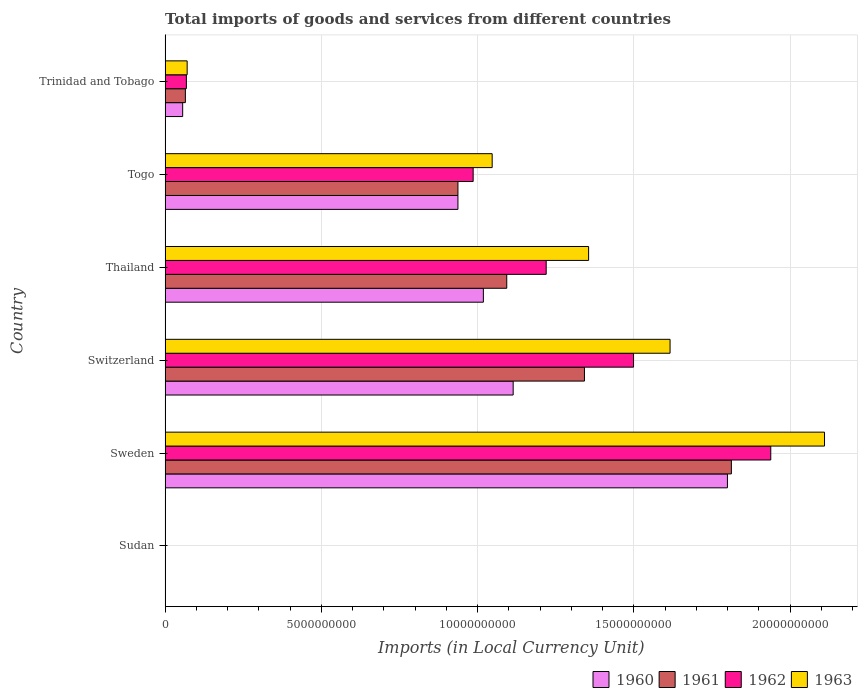How many groups of bars are there?
Your answer should be very brief. 6. Are the number of bars per tick equal to the number of legend labels?
Provide a succinct answer. Yes. Are the number of bars on each tick of the Y-axis equal?
Ensure brevity in your answer.  Yes. How many bars are there on the 6th tick from the top?
Offer a terse response. 4. What is the label of the 5th group of bars from the top?
Your answer should be compact. Sweden. In how many cases, is the number of bars for a given country not equal to the number of legend labels?
Your answer should be very brief. 0. What is the Amount of goods and services imports in 1961 in Trinidad and Tobago?
Provide a succinct answer. 6.49e+08. Across all countries, what is the maximum Amount of goods and services imports in 1962?
Provide a short and direct response. 1.94e+1. Across all countries, what is the minimum Amount of goods and services imports in 1963?
Your answer should be compact. 8.49e+04. In which country was the Amount of goods and services imports in 1962 minimum?
Offer a terse response. Sudan. What is the total Amount of goods and services imports in 1960 in the graph?
Ensure brevity in your answer.  4.92e+1. What is the difference between the Amount of goods and services imports in 1963 in Sudan and that in Sweden?
Offer a terse response. -2.11e+1. What is the difference between the Amount of goods and services imports in 1960 in Togo and the Amount of goods and services imports in 1961 in Thailand?
Your answer should be very brief. -1.56e+09. What is the average Amount of goods and services imports in 1961 per country?
Give a very brief answer. 8.75e+09. What is the difference between the Amount of goods and services imports in 1962 and Amount of goods and services imports in 1961 in Sweden?
Offer a terse response. 1.26e+09. In how many countries, is the Amount of goods and services imports in 1961 greater than 13000000000 LCU?
Your response must be concise. 2. What is the ratio of the Amount of goods and services imports in 1962 in Sudan to that in Togo?
Keep it short and to the point. 7.0611131633880305e-6. What is the difference between the highest and the second highest Amount of goods and services imports in 1962?
Your response must be concise. 4.39e+09. What is the difference between the highest and the lowest Amount of goods and services imports in 1961?
Make the answer very short. 1.81e+1. Is it the case that in every country, the sum of the Amount of goods and services imports in 1960 and Amount of goods and services imports in 1963 is greater than the sum of Amount of goods and services imports in 1962 and Amount of goods and services imports in 1961?
Give a very brief answer. No. What does the 1st bar from the top in Thailand represents?
Offer a terse response. 1963. Are all the bars in the graph horizontal?
Your response must be concise. Yes. How many countries are there in the graph?
Provide a short and direct response. 6. What is the difference between two consecutive major ticks on the X-axis?
Keep it short and to the point. 5.00e+09. Where does the legend appear in the graph?
Make the answer very short. Bottom right. What is the title of the graph?
Offer a terse response. Total imports of goods and services from different countries. What is the label or title of the X-axis?
Provide a succinct answer. Imports (in Local Currency Unit). What is the label or title of the Y-axis?
Give a very brief answer. Country. What is the Imports (in Local Currency Unit) of 1960 in Sudan?
Your answer should be very brief. 5.10e+04. What is the Imports (in Local Currency Unit) of 1961 in Sudan?
Your answer should be compact. 6.11e+04. What is the Imports (in Local Currency Unit) of 1962 in Sudan?
Your answer should be very brief. 6.96e+04. What is the Imports (in Local Currency Unit) of 1963 in Sudan?
Keep it short and to the point. 8.49e+04. What is the Imports (in Local Currency Unit) of 1960 in Sweden?
Your response must be concise. 1.80e+1. What is the Imports (in Local Currency Unit) of 1961 in Sweden?
Offer a terse response. 1.81e+1. What is the Imports (in Local Currency Unit) in 1962 in Sweden?
Provide a succinct answer. 1.94e+1. What is the Imports (in Local Currency Unit) of 1963 in Sweden?
Provide a short and direct response. 2.11e+1. What is the Imports (in Local Currency Unit) of 1960 in Switzerland?
Offer a very short reply. 1.11e+1. What is the Imports (in Local Currency Unit) in 1961 in Switzerland?
Make the answer very short. 1.34e+1. What is the Imports (in Local Currency Unit) of 1962 in Switzerland?
Offer a very short reply. 1.50e+1. What is the Imports (in Local Currency Unit) of 1963 in Switzerland?
Keep it short and to the point. 1.62e+1. What is the Imports (in Local Currency Unit) in 1960 in Thailand?
Your answer should be compact. 1.02e+1. What is the Imports (in Local Currency Unit) of 1961 in Thailand?
Ensure brevity in your answer.  1.09e+1. What is the Imports (in Local Currency Unit) of 1962 in Thailand?
Make the answer very short. 1.22e+1. What is the Imports (in Local Currency Unit) in 1963 in Thailand?
Offer a very short reply. 1.36e+1. What is the Imports (in Local Currency Unit) in 1960 in Togo?
Make the answer very short. 9.37e+09. What is the Imports (in Local Currency Unit) in 1961 in Togo?
Your answer should be compact. 9.37e+09. What is the Imports (in Local Currency Unit) in 1962 in Togo?
Make the answer very short. 9.86e+09. What is the Imports (in Local Currency Unit) of 1963 in Togo?
Offer a terse response. 1.05e+1. What is the Imports (in Local Currency Unit) of 1960 in Trinidad and Tobago?
Make the answer very short. 5.62e+08. What is the Imports (in Local Currency Unit) of 1961 in Trinidad and Tobago?
Offer a very short reply. 6.49e+08. What is the Imports (in Local Currency Unit) of 1962 in Trinidad and Tobago?
Give a very brief answer. 6.81e+08. What is the Imports (in Local Currency Unit) in 1963 in Trinidad and Tobago?
Offer a terse response. 7.06e+08. Across all countries, what is the maximum Imports (in Local Currency Unit) in 1960?
Provide a short and direct response. 1.80e+1. Across all countries, what is the maximum Imports (in Local Currency Unit) in 1961?
Offer a terse response. 1.81e+1. Across all countries, what is the maximum Imports (in Local Currency Unit) in 1962?
Offer a terse response. 1.94e+1. Across all countries, what is the maximum Imports (in Local Currency Unit) of 1963?
Your answer should be very brief. 2.11e+1. Across all countries, what is the minimum Imports (in Local Currency Unit) in 1960?
Your answer should be very brief. 5.10e+04. Across all countries, what is the minimum Imports (in Local Currency Unit) of 1961?
Your answer should be very brief. 6.11e+04. Across all countries, what is the minimum Imports (in Local Currency Unit) in 1962?
Give a very brief answer. 6.96e+04. Across all countries, what is the minimum Imports (in Local Currency Unit) of 1963?
Offer a terse response. 8.49e+04. What is the total Imports (in Local Currency Unit) of 1960 in the graph?
Provide a short and direct response. 4.92e+1. What is the total Imports (in Local Currency Unit) of 1961 in the graph?
Make the answer very short. 5.25e+1. What is the total Imports (in Local Currency Unit) in 1962 in the graph?
Ensure brevity in your answer.  5.71e+1. What is the total Imports (in Local Currency Unit) of 1963 in the graph?
Your answer should be compact. 6.20e+1. What is the difference between the Imports (in Local Currency Unit) of 1960 in Sudan and that in Sweden?
Your response must be concise. -1.80e+1. What is the difference between the Imports (in Local Currency Unit) of 1961 in Sudan and that in Sweden?
Make the answer very short. -1.81e+1. What is the difference between the Imports (in Local Currency Unit) of 1962 in Sudan and that in Sweden?
Offer a very short reply. -1.94e+1. What is the difference between the Imports (in Local Currency Unit) in 1963 in Sudan and that in Sweden?
Make the answer very short. -2.11e+1. What is the difference between the Imports (in Local Currency Unit) of 1960 in Sudan and that in Switzerland?
Make the answer very short. -1.11e+1. What is the difference between the Imports (in Local Currency Unit) of 1961 in Sudan and that in Switzerland?
Your answer should be compact. -1.34e+1. What is the difference between the Imports (in Local Currency Unit) in 1962 in Sudan and that in Switzerland?
Make the answer very short. -1.50e+1. What is the difference between the Imports (in Local Currency Unit) of 1963 in Sudan and that in Switzerland?
Your answer should be very brief. -1.62e+1. What is the difference between the Imports (in Local Currency Unit) in 1960 in Sudan and that in Thailand?
Give a very brief answer. -1.02e+1. What is the difference between the Imports (in Local Currency Unit) of 1961 in Sudan and that in Thailand?
Your answer should be very brief. -1.09e+1. What is the difference between the Imports (in Local Currency Unit) in 1962 in Sudan and that in Thailand?
Make the answer very short. -1.22e+1. What is the difference between the Imports (in Local Currency Unit) in 1963 in Sudan and that in Thailand?
Your answer should be very brief. -1.36e+1. What is the difference between the Imports (in Local Currency Unit) in 1960 in Sudan and that in Togo?
Provide a succinct answer. -9.37e+09. What is the difference between the Imports (in Local Currency Unit) in 1961 in Sudan and that in Togo?
Offer a terse response. -9.37e+09. What is the difference between the Imports (in Local Currency Unit) of 1962 in Sudan and that in Togo?
Provide a succinct answer. -9.86e+09. What is the difference between the Imports (in Local Currency Unit) of 1963 in Sudan and that in Togo?
Give a very brief answer. -1.05e+1. What is the difference between the Imports (in Local Currency Unit) in 1960 in Sudan and that in Trinidad and Tobago?
Ensure brevity in your answer.  -5.62e+08. What is the difference between the Imports (in Local Currency Unit) of 1961 in Sudan and that in Trinidad and Tobago?
Offer a very short reply. -6.49e+08. What is the difference between the Imports (in Local Currency Unit) of 1962 in Sudan and that in Trinidad and Tobago?
Your answer should be compact. -6.81e+08. What is the difference between the Imports (in Local Currency Unit) in 1963 in Sudan and that in Trinidad and Tobago?
Offer a very short reply. -7.06e+08. What is the difference between the Imports (in Local Currency Unit) in 1960 in Sweden and that in Switzerland?
Provide a short and direct response. 6.86e+09. What is the difference between the Imports (in Local Currency Unit) in 1961 in Sweden and that in Switzerland?
Offer a very short reply. 4.70e+09. What is the difference between the Imports (in Local Currency Unit) of 1962 in Sweden and that in Switzerland?
Keep it short and to the point. 4.39e+09. What is the difference between the Imports (in Local Currency Unit) in 1963 in Sweden and that in Switzerland?
Offer a terse response. 4.94e+09. What is the difference between the Imports (in Local Currency Unit) of 1960 in Sweden and that in Thailand?
Offer a terse response. 7.81e+09. What is the difference between the Imports (in Local Currency Unit) in 1961 in Sweden and that in Thailand?
Your answer should be compact. 7.19e+09. What is the difference between the Imports (in Local Currency Unit) in 1962 in Sweden and that in Thailand?
Your answer should be very brief. 7.19e+09. What is the difference between the Imports (in Local Currency Unit) in 1963 in Sweden and that in Thailand?
Keep it short and to the point. 7.55e+09. What is the difference between the Imports (in Local Currency Unit) in 1960 in Sweden and that in Togo?
Offer a terse response. 8.62e+09. What is the difference between the Imports (in Local Currency Unit) of 1961 in Sweden and that in Togo?
Offer a very short reply. 8.75e+09. What is the difference between the Imports (in Local Currency Unit) of 1962 in Sweden and that in Togo?
Keep it short and to the point. 9.52e+09. What is the difference between the Imports (in Local Currency Unit) of 1963 in Sweden and that in Togo?
Provide a succinct answer. 1.06e+1. What is the difference between the Imports (in Local Currency Unit) of 1960 in Sweden and that in Trinidad and Tobago?
Offer a terse response. 1.74e+1. What is the difference between the Imports (in Local Currency Unit) of 1961 in Sweden and that in Trinidad and Tobago?
Offer a terse response. 1.75e+1. What is the difference between the Imports (in Local Currency Unit) of 1962 in Sweden and that in Trinidad and Tobago?
Your answer should be compact. 1.87e+1. What is the difference between the Imports (in Local Currency Unit) in 1963 in Sweden and that in Trinidad and Tobago?
Your answer should be very brief. 2.04e+1. What is the difference between the Imports (in Local Currency Unit) of 1960 in Switzerland and that in Thailand?
Give a very brief answer. 9.53e+08. What is the difference between the Imports (in Local Currency Unit) in 1961 in Switzerland and that in Thailand?
Your answer should be compact. 2.49e+09. What is the difference between the Imports (in Local Currency Unit) of 1962 in Switzerland and that in Thailand?
Provide a succinct answer. 2.80e+09. What is the difference between the Imports (in Local Currency Unit) in 1963 in Switzerland and that in Thailand?
Your answer should be compact. 2.61e+09. What is the difference between the Imports (in Local Currency Unit) in 1960 in Switzerland and that in Togo?
Offer a very short reply. 1.77e+09. What is the difference between the Imports (in Local Currency Unit) of 1961 in Switzerland and that in Togo?
Make the answer very short. 4.05e+09. What is the difference between the Imports (in Local Currency Unit) of 1962 in Switzerland and that in Togo?
Provide a succinct answer. 5.13e+09. What is the difference between the Imports (in Local Currency Unit) in 1963 in Switzerland and that in Togo?
Make the answer very short. 5.69e+09. What is the difference between the Imports (in Local Currency Unit) of 1960 in Switzerland and that in Trinidad and Tobago?
Provide a succinct answer. 1.06e+1. What is the difference between the Imports (in Local Currency Unit) in 1961 in Switzerland and that in Trinidad and Tobago?
Offer a terse response. 1.28e+1. What is the difference between the Imports (in Local Currency Unit) in 1962 in Switzerland and that in Trinidad and Tobago?
Offer a terse response. 1.43e+1. What is the difference between the Imports (in Local Currency Unit) in 1963 in Switzerland and that in Trinidad and Tobago?
Your answer should be very brief. 1.55e+1. What is the difference between the Imports (in Local Currency Unit) in 1960 in Thailand and that in Togo?
Offer a very short reply. 8.14e+08. What is the difference between the Imports (in Local Currency Unit) of 1961 in Thailand and that in Togo?
Offer a very short reply. 1.56e+09. What is the difference between the Imports (in Local Currency Unit) in 1962 in Thailand and that in Togo?
Make the answer very short. 2.34e+09. What is the difference between the Imports (in Local Currency Unit) of 1963 in Thailand and that in Togo?
Your answer should be very brief. 3.09e+09. What is the difference between the Imports (in Local Currency Unit) in 1960 in Thailand and that in Trinidad and Tobago?
Keep it short and to the point. 9.62e+09. What is the difference between the Imports (in Local Currency Unit) in 1961 in Thailand and that in Trinidad and Tobago?
Offer a terse response. 1.03e+1. What is the difference between the Imports (in Local Currency Unit) in 1962 in Thailand and that in Trinidad and Tobago?
Ensure brevity in your answer.  1.15e+1. What is the difference between the Imports (in Local Currency Unit) of 1963 in Thailand and that in Trinidad and Tobago?
Your response must be concise. 1.28e+1. What is the difference between the Imports (in Local Currency Unit) of 1960 in Togo and that in Trinidad and Tobago?
Ensure brevity in your answer.  8.81e+09. What is the difference between the Imports (in Local Currency Unit) of 1961 in Togo and that in Trinidad and Tobago?
Give a very brief answer. 8.72e+09. What is the difference between the Imports (in Local Currency Unit) of 1962 in Togo and that in Trinidad and Tobago?
Give a very brief answer. 9.18e+09. What is the difference between the Imports (in Local Currency Unit) in 1963 in Togo and that in Trinidad and Tobago?
Make the answer very short. 9.76e+09. What is the difference between the Imports (in Local Currency Unit) in 1960 in Sudan and the Imports (in Local Currency Unit) in 1961 in Sweden?
Your answer should be very brief. -1.81e+1. What is the difference between the Imports (in Local Currency Unit) in 1960 in Sudan and the Imports (in Local Currency Unit) in 1962 in Sweden?
Give a very brief answer. -1.94e+1. What is the difference between the Imports (in Local Currency Unit) of 1960 in Sudan and the Imports (in Local Currency Unit) of 1963 in Sweden?
Offer a terse response. -2.11e+1. What is the difference between the Imports (in Local Currency Unit) in 1961 in Sudan and the Imports (in Local Currency Unit) in 1962 in Sweden?
Provide a succinct answer. -1.94e+1. What is the difference between the Imports (in Local Currency Unit) in 1961 in Sudan and the Imports (in Local Currency Unit) in 1963 in Sweden?
Keep it short and to the point. -2.11e+1. What is the difference between the Imports (in Local Currency Unit) of 1962 in Sudan and the Imports (in Local Currency Unit) of 1963 in Sweden?
Your answer should be very brief. -2.11e+1. What is the difference between the Imports (in Local Currency Unit) of 1960 in Sudan and the Imports (in Local Currency Unit) of 1961 in Switzerland?
Ensure brevity in your answer.  -1.34e+1. What is the difference between the Imports (in Local Currency Unit) in 1960 in Sudan and the Imports (in Local Currency Unit) in 1962 in Switzerland?
Offer a very short reply. -1.50e+1. What is the difference between the Imports (in Local Currency Unit) in 1960 in Sudan and the Imports (in Local Currency Unit) in 1963 in Switzerland?
Your response must be concise. -1.62e+1. What is the difference between the Imports (in Local Currency Unit) in 1961 in Sudan and the Imports (in Local Currency Unit) in 1962 in Switzerland?
Keep it short and to the point. -1.50e+1. What is the difference between the Imports (in Local Currency Unit) of 1961 in Sudan and the Imports (in Local Currency Unit) of 1963 in Switzerland?
Provide a short and direct response. -1.62e+1. What is the difference between the Imports (in Local Currency Unit) of 1962 in Sudan and the Imports (in Local Currency Unit) of 1963 in Switzerland?
Your answer should be very brief. -1.62e+1. What is the difference between the Imports (in Local Currency Unit) in 1960 in Sudan and the Imports (in Local Currency Unit) in 1961 in Thailand?
Give a very brief answer. -1.09e+1. What is the difference between the Imports (in Local Currency Unit) of 1960 in Sudan and the Imports (in Local Currency Unit) of 1962 in Thailand?
Offer a very short reply. -1.22e+1. What is the difference between the Imports (in Local Currency Unit) of 1960 in Sudan and the Imports (in Local Currency Unit) of 1963 in Thailand?
Offer a terse response. -1.36e+1. What is the difference between the Imports (in Local Currency Unit) of 1961 in Sudan and the Imports (in Local Currency Unit) of 1962 in Thailand?
Your answer should be compact. -1.22e+1. What is the difference between the Imports (in Local Currency Unit) of 1961 in Sudan and the Imports (in Local Currency Unit) of 1963 in Thailand?
Make the answer very short. -1.36e+1. What is the difference between the Imports (in Local Currency Unit) in 1962 in Sudan and the Imports (in Local Currency Unit) in 1963 in Thailand?
Provide a succinct answer. -1.36e+1. What is the difference between the Imports (in Local Currency Unit) in 1960 in Sudan and the Imports (in Local Currency Unit) in 1961 in Togo?
Provide a succinct answer. -9.37e+09. What is the difference between the Imports (in Local Currency Unit) of 1960 in Sudan and the Imports (in Local Currency Unit) of 1962 in Togo?
Keep it short and to the point. -9.86e+09. What is the difference between the Imports (in Local Currency Unit) of 1960 in Sudan and the Imports (in Local Currency Unit) of 1963 in Togo?
Your answer should be very brief. -1.05e+1. What is the difference between the Imports (in Local Currency Unit) in 1961 in Sudan and the Imports (in Local Currency Unit) in 1962 in Togo?
Ensure brevity in your answer.  -9.86e+09. What is the difference between the Imports (in Local Currency Unit) of 1961 in Sudan and the Imports (in Local Currency Unit) of 1963 in Togo?
Offer a terse response. -1.05e+1. What is the difference between the Imports (in Local Currency Unit) in 1962 in Sudan and the Imports (in Local Currency Unit) in 1963 in Togo?
Provide a short and direct response. -1.05e+1. What is the difference between the Imports (in Local Currency Unit) of 1960 in Sudan and the Imports (in Local Currency Unit) of 1961 in Trinidad and Tobago?
Offer a terse response. -6.49e+08. What is the difference between the Imports (in Local Currency Unit) of 1960 in Sudan and the Imports (in Local Currency Unit) of 1962 in Trinidad and Tobago?
Your answer should be very brief. -6.81e+08. What is the difference between the Imports (in Local Currency Unit) in 1960 in Sudan and the Imports (in Local Currency Unit) in 1963 in Trinidad and Tobago?
Give a very brief answer. -7.06e+08. What is the difference between the Imports (in Local Currency Unit) of 1961 in Sudan and the Imports (in Local Currency Unit) of 1962 in Trinidad and Tobago?
Your answer should be very brief. -6.81e+08. What is the difference between the Imports (in Local Currency Unit) in 1961 in Sudan and the Imports (in Local Currency Unit) in 1963 in Trinidad and Tobago?
Offer a very short reply. -7.06e+08. What is the difference between the Imports (in Local Currency Unit) in 1962 in Sudan and the Imports (in Local Currency Unit) in 1963 in Trinidad and Tobago?
Offer a terse response. -7.06e+08. What is the difference between the Imports (in Local Currency Unit) in 1960 in Sweden and the Imports (in Local Currency Unit) in 1961 in Switzerland?
Offer a terse response. 4.57e+09. What is the difference between the Imports (in Local Currency Unit) of 1960 in Sweden and the Imports (in Local Currency Unit) of 1962 in Switzerland?
Your answer should be compact. 3.00e+09. What is the difference between the Imports (in Local Currency Unit) of 1960 in Sweden and the Imports (in Local Currency Unit) of 1963 in Switzerland?
Give a very brief answer. 1.84e+09. What is the difference between the Imports (in Local Currency Unit) in 1961 in Sweden and the Imports (in Local Currency Unit) in 1962 in Switzerland?
Offer a terse response. 3.13e+09. What is the difference between the Imports (in Local Currency Unit) in 1961 in Sweden and the Imports (in Local Currency Unit) in 1963 in Switzerland?
Your response must be concise. 1.96e+09. What is the difference between the Imports (in Local Currency Unit) in 1962 in Sweden and the Imports (in Local Currency Unit) in 1963 in Switzerland?
Offer a terse response. 3.22e+09. What is the difference between the Imports (in Local Currency Unit) of 1960 in Sweden and the Imports (in Local Currency Unit) of 1961 in Thailand?
Ensure brevity in your answer.  7.06e+09. What is the difference between the Imports (in Local Currency Unit) in 1960 in Sweden and the Imports (in Local Currency Unit) in 1962 in Thailand?
Your answer should be compact. 5.80e+09. What is the difference between the Imports (in Local Currency Unit) of 1960 in Sweden and the Imports (in Local Currency Unit) of 1963 in Thailand?
Your response must be concise. 4.44e+09. What is the difference between the Imports (in Local Currency Unit) in 1961 in Sweden and the Imports (in Local Currency Unit) in 1962 in Thailand?
Your answer should be compact. 5.93e+09. What is the difference between the Imports (in Local Currency Unit) of 1961 in Sweden and the Imports (in Local Currency Unit) of 1963 in Thailand?
Your answer should be compact. 4.57e+09. What is the difference between the Imports (in Local Currency Unit) in 1962 in Sweden and the Imports (in Local Currency Unit) in 1963 in Thailand?
Your answer should be compact. 5.83e+09. What is the difference between the Imports (in Local Currency Unit) of 1960 in Sweden and the Imports (in Local Currency Unit) of 1961 in Togo?
Make the answer very short. 8.62e+09. What is the difference between the Imports (in Local Currency Unit) in 1960 in Sweden and the Imports (in Local Currency Unit) in 1962 in Togo?
Make the answer very short. 8.14e+09. What is the difference between the Imports (in Local Currency Unit) of 1960 in Sweden and the Imports (in Local Currency Unit) of 1963 in Togo?
Give a very brief answer. 7.53e+09. What is the difference between the Imports (in Local Currency Unit) in 1961 in Sweden and the Imports (in Local Currency Unit) in 1962 in Togo?
Ensure brevity in your answer.  8.26e+09. What is the difference between the Imports (in Local Currency Unit) in 1961 in Sweden and the Imports (in Local Currency Unit) in 1963 in Togo?
Keep it short and to the point. 7.65e+09. What is the difference between the Imports (in Local Currency Unit) of 1962 in Sweden and the Imports (in Local Currency Unit) of 1963 in Togo?
Keep it short and to the point. 8.91e+09. What is the difference between the Imports (in Local Currency Unit) in 1960 in Sweden and the Imports (in Local Currency Unit) in 1961 in Trinidad and Tobago?
Your answer should be compact. 1.73e+1. What is the difference between the Imports (in Local Currency Unit) of 1960 in Sweden and the Imports (in Local Currency Unit) of 1962 in Trinidad and Tobago?
Give a very brief answer. 1.73e+1. What is the difference between the Imports (in Local Currency Unit) of 1960 in Sweden and the Imports (in Local Currency Unit) of 1963 in Trinidad and Tobago?
Provide a succinct answer. 1.73e+1. What is the difference between the Imports (in Local Currency Unit) in 1961 in Sweden and the Imports (in Local Currency Unit) in 1962 in Trinidad and Tobago?
Give a very brief answer. 1.74e+1. What is the difference between the Imports (in Local Currency Unit) of 1961 in Sweden and the Imports (in Local Currency Unit) of 1963 in Trinidad and Tobago?
Offer a very short reply. 1.74e+1. What is the difference between the Imports (in Local Currency Unit) of 1962 in Sweden and the Imports (in Local Currency Unit) of 1963 in Trinidad and Tobago?
Give a very brief answer. 1.87e+1. What is the difference between the Imports (in Local Currency Unit) in 1960 in Switzerland and the Imports (in Local Currency Unit) in 1961 in Thailand?
Your answer should be compact. 2.05e+08. What is the difference between the Imports (in Local Currency Unit) in 1960 in Switzerland and the Imports (in Local Currency Unit) in 1962 in Thailand?
Make the answer very short. -1.06e+09. What is the difference between the Imports (in Local Currency Unit) of 1960 in Switzerland and the Imports (in Local Currency Unit) of 1963 in Thailand?
Ensure brevity in your answer.  -2.41e+09. What is the difference between the Imports (in Local Currency Unit) of 1961 in Switzerland and the Imports (in Local Currency Unit) of 1962 in Thailand?
Make the answer very short. 1.22e+09. What is the difference between the Imports (in Local Currency Unit) in 1961 in Switzerland and the Imports (in Local Currency Unit) in 1963 in Thailand?
Offer a terse response. -1.33e+08. What is the difference between the Imports (in Local Currency Unit) of 1962 in Switzerland and the Imports (in Local Currency Unit) of 1963 in Thailand?
Provide a succinct answer. 1.44e+09. What is the difference between the Imports (in Local Currency Unit) in 1960 in Switzerland and the Imports (in Local Currency Unit) in 1961 in Togo?
Offer a very short reply. 1.77e+09. What is the difference between the Imports (in Local Currency Unit) in 1960 in Switzerland and the Imports (in Local Currency Unit) in 1962 in Togo?
Your answer should be very brief. 1.28e+09. What is the difference between the Imports (in Local Currency Unit) in 1960 in Switzerland and the Imports (in Local Currency Unit) in 1963 in Togo?
Give a very brief answer. 6.72e+08. What is the difference between the Imports (in Local Currency Unit) of 1961 in Switzerland and the Imports (in Local Currency Unit) of 1962 in Togo?
Keep it short and to the point. 3.56e+09. What is the difference between the Imports (in Local Currency Unit) in 1961 in Switzerland and the Imports (in Local Currency Unit) in 1963 in Togo?
Provide a short and direct response. 2.95e+09. What is the difference between the Imports (in Local Currency Unit) in 1962 in Switzerland and the Imports (in Local Currency Unit) in 1963 in Togo?
Offer a terse response. 4.52e+09. What is the difference between the Imports (in Local Currency Unit) in 1960 in Switzerland and the Imports (in Local Currency Unit) in 1961 in Trinidad and Tobago?
Offer a terse response. 1.05e+1. What is the difference between the Imports (in Local Currency Unit) in 1960 in Switzerland and the Imports (in Local Currency Unit) in 1962 in Trinidad and Tobago?
Provide a succinct answer. 1.05e+1. What is the difference between the Imports (in Local Currency Unit) of 1960 in Switzerland and the Imports (in Local Currency Unit) of 1963 in Trinidad and Tobago?
Give a very brief answer. 1.04e+1. What is the difference between the Imports (in Local Currency Unit) of 1961 in Switzerland and the Imports (in Local Currency Unit) of 1962 in Trinidad and Tobago?
Keep it short and to the point. 1.27e+1. What is the difference between the Imports (in Local Currency Unit) of 1961 in Switzerland and the Imports (in Local Currency Unit) of 1963 in Trinidad and Tobago?
Keep it short and to the point. 1.27e+1. What is the difference between the Imports (in Local Currency Unit) in 1962 in Switzerland and the Imports (in Local Currency Unit) in 1963 in Trinidad and Tobago?
Provide a short and direct response. 1.43e+1. What is the difference between the Imports (in Local Currency Unit) of 1960 in Thailand and the Imports (in Local Currency Unit) of 1961 in Togo?
Ensure brevity in your answer.  8.14e+08. What is the difference between the Imports (in Local Currency Unit) in 1960 in Thailand and the Imports (in Local Currency Unit) in 1962 in Togo?
Provide a short and direct response. 3.27e+08. What is the difference between the Imports (in Local Currency Unit) of 1960 in Thailand and the Imports (in Local Currency Unit) of 1963 in Togo?
Your answer should be very brief. -2.81e+08. What is the difference between the Imports (in Local Currency Unit) of 1961 in Thailand and the Imports (in Local Currency Unit) of 1962 in Togo?
Your answer should be very brief. 1.08e+09. What is the difference between the Imports (in Local Currency Unit) in 1961 in Thailand and the Imports (in Local Currency Unit) in 1963 in Togo?
Your response must be concise. 4.67e+08. What is the difference between the Imports (in Local Currency Unit) in 1962 in Thailand and the Imports (in Local Currency Unit) in 1963 in Togo?
Ensure brevity in your answer.  1.73e+09. What is the difference between the Imports (in Local Currency Unit) in 1960 in Thailand and the Imports (in Local Currency Unit) in 1961 in Trinidad and Tobago?
Your answer should be compact. 9.54e+09. What is the difference between the Imports (in Local Currency Unit) of 1960 in Thailand and the Imports (in Local Currency Unit) of 1962 in Trinidad and Tobago?
Keep it short and to the point. 9.50e+09. What is the difference between the Imports (in Local Currency Unit) of 1960 in Thailand and the Imports (in Local Currency Unit) of 1963 in Trinidad and Tobago?
Your answer should be compact. 9.48e+09. What is the difference between the Imports (in Local Currency Unit) in 1961 in Thailand and the Imports (in Local Currency Unit) in 1962 in Trinidad and Tobago?
Provide a succinct answer. 1.03e+1. What is the difference between the Imports (in Local Currency Unit) of 1961 in Thailand and the Imports (in Local Currency Unit) of 1963 in Trinidad and Tobago?
Give a very brief answer. 1.02e+1. What is the difference between the Imports (in Local Currency Unit) of 1962 in Thailand and the Imports (in Local Currency Unit) of 1963 in Trinidad and Tobago?
Give a very brief answer. 1.15e+1. What is the difference between the Imports (in Local Currency Unit) of 1960 in Togo and the Imports (in Local Currency Unit) of 1961 in Trinidad and Tobago?
Offer a very short reply. 8.72e+09. What is the difference between the Imports (in Local Currency Unit) in 1960 in Togo and the Imports (in Local Currency Unit) in 1962 in Trinidad and Tobago?
Give a very brief answer. 8.69e+09. What is the difference between the Imports (in Local Currency Unit) of 1960 in Togo and the Imports (in Local Currency Unit) of 1963 in Trinidad and Tobago?
Ensure brevity in your answer.  8.66e+09. What is the difference between the Imports (in Local Currency Unit) in 1961 in Togo and the Imports (in Local Currency Unit) in 1962 in Trinidad and Tobago?
Offer a very short reply. 8.69e+09. What is the difference between the Imports (in Local Currency Unit) in 1961 in Togo and the Imports (in Local Currency Unit) in 1963 in Trinidad and Tobago?
Your answer should be compact. 8.66e+09. What is the difference between the Imports (in Local Currency Unit) of 1962 in Togo and the Imports (in Local Currency Unit) of 1963 in Trinidad and Tobago?
Offer a terse response. 9.15e+09. What is the average Imports (in Local Currency Unit) in 1960 per country?
Ensure brevity in your answer.  8.21e+09. What is the average Imports (in Local Currency Unit) of 1961 per country?
Provide a succinct answer. 8.75e+09. What is the average Imports (in Local Currency Unit) in 1962 per country?
Give a very brief answer. 9.52e+09. What is the average Imports (in Local Currency Unit) in 1963 per country?
Keep it short and to the point. 1.03e+1. What is the difference between the Imports (in Local Currency Unit) of 1960 and Imports (in Local Currency Unit) of 1961 in Sudan?
Provide a succinct answer. -1.01e+04. What is the difference between the Imports (in Local Currency Unit) of 1960 and Imports (in Local Currency Unit) of 1962 in Sudan?
Make the answer very short. -1.86e+04. What is the difference between the Imports (in Local Currency Unit) of 1960 and Imports (in Local Currency Unit) of 1963 in Sudan?
Your answer should be very brief. -3.39e+04. What is the difference between the Imports (in Local Currency Unit) of 1961 and Imports (in Local Currency Unit) of 1962 in Sudan?
Provide a succinct answer. -8500. What is the difference between the Imports (in Local Currency Unit) of 1961 and Imports (in Local Currency Unit) of 1963 in Sudan?
Provide a short and direct response. -2.38e+04. What is the difference between the Imports (in Local Currency Unit) of 1962 and Imports (in Local Currency Unit) of 1963 in Sudan?
Make the answer very short. -1.53e+04. What is the difference between the Imports (in Local Currency Unit) in 1960 and Imports (in Local Currency Unit) in 1961 in Sweden?
Provide a short and direct response. -1.26e+08. What is the difference between the Imports (in Local Currency Unit) of 1960 and Imports (in Local Currency Unit) of 1962 in Sweden?
Give a very brief answer. -1.39e+09. What is the difference between the Imports (in Local Currency Unit) in 1960 and Imports (in Local Currency Unit) in 1963 in Sweden?
Offer a very short reply. -3.11e+09. What is the difference between the Imports (in Local Currency Unit) of 1961 and Imports (in Local Currency Unit) of 1962 in Sweden?
Provide a short and direct response. -1.26e+09. What is the difference between the Imports (in Local Currency Unit) in 1961 and Imports (in Local Currency Unit) in 1963 in Sweden?
Ensure brevity in your answer.  -2.98e+09. What is the difference between the Imports (in Local Currency Unit) of 1962 and Imports (in Local Currency Unit) of 1963 in Sweden?
Make the answer very short. -1.72e+09. What is the difference between the Imports (in Local Currency Unit) of 1960 and Imports (in Local Currency Unit) of 1961 in Switzerland?
Your answer should be compact. -2.28e+09. What is the difference between the Imports (in Local Currency Unit) of 1960 and Imports (in Local Currency Unit) of 1962 in Switzerland?
Keep it short and to the point. -3.85e+09. What is the difference between the Imports (in Local Currency Unit) in 1960 and Imports (in Local Currency Unit) in 1963 in Switzerland?
Provide a succinct answer. -5.02e+09. What is the difference between the Imports (in Local Currency Unit) in 1961 and Imports (in Local Currency Unit) in 1962 in Switzerland?
Your response must be concise. -1.57e+09. What is the difference between the Imports (in Local Currency Unit) of 1961 and Imports (in Local Currency Unit) of 1963 in Switzerland?
Provide a short and direct response. -2.74e+09. What is the difference between the Imports (in Local Currency Unit) in 1962 and Imports (in Local Currency Unit) in 1963 in Switzerland?
Offer a very short reply. -1.17e+09. What is the difference between the Imports (in Local Currency Unit) in 1960 and Imports (in Local Currency Unit) in 1961 in Thailand?
Ensure brevity in your answer.  -7.48e+08. What is the difference between the Imports (in Local Currency Unit) in 1960 and Imports (in Local Currency Unit) in 1962 in Thailand?
Provide a short and direct response. -2.01e+09. What is the difference between the Imports (in Local Currency Unit) of 1960 and Imports (in Local Currency Unit) of 1963 in Thailand?
Keep it short and to the point. -3.37e+09. What is the difference between the Imports (in Local Currency Unit) in 1961 and Imports (in Local Currency Unit) in 1962 in Thailand?
Offer a terse response. -1.26e+09. What is the difference between the Imports (in Local Currency Unit) in 1961 and Imports (in Local Currency Unit) in 1963 in Thailand?
Your answer should be very brief. -2.62e+09. What is the difference between the Imports (in Local Currency Unit) in 1962 and Imports (in Local Currency Unit) in 1963 in Thailand?
Your answer should be very brief. -1.36e+09. What is the difference between the Imports (in Local Currency Unit) in 1960 and Imports (in Local Currency Unit) in 1962 in Togo?
Your answer should be very brief. -4.87e+08. What is the difference between the Imports (in Local Currency Unit) in 1960 and Imports (in Local Currency Unit) in 1963 in Togo?
Give a very brief answer. -1.10e+09. What is the difference between the Imports (in Local Currency Unit) of 1961 and Imports (in Local Currency Unit) of 1962 in Togo?
Give a very brief answer. -4.87e+08. What is the difference between the Imports (in Local Currency Unit) in 1961 and Imports (in Local Currency Unit) in 1963 in Togo?
Make the answer very short. -1.10e+09. What is the difference between the Imports (in Local Currency Unit) in 1962 and Imports (in Local Currency Unit) in 1963 in Togo?
Keep it short and to the point. -6.08e+08. What is the difference between the Imports (in Local Currency Unit) of 1960 and Imports (in Local Currency Unit) of 1961 in Trinidad and Tobago?
Your answer should be very brief. -8.67e+07. What is the difference between the Imports (in Local Currency Unit) in 1960 and Imports (in Local Currency Unit) in 1962 in Trinidad and Tobago?
Offer a terse response. -1.18e+08. What is the difference between the Imports (in Local Currency Unit) of 1960 and Imports (in Local Currency Unit) of 1963 in Trinidad and Tobago?
Provide a short and direct response. -1.44e+08. What is the difference between the Imports (in Local Currency Unit) in 1961 and Imports (in Local Currency Unit) in 1962 in Trinidad and Tobago?
Ensure brevity in your answer.  -3.17e+07. What is the difference between the Imports (in Local Currency Unit) in 1961 and Imports (in Local Currency Unit) in 1963 in Trinidad and Tobago?
Make the answer very short. -5.69e+07. What is the difference between the Imports (in Local Currency Unit) of 1962 and Imports (in Local Currency Unit) of 1963 in Trinidad and Tobago?
Offer a very short reply. -2.52e+07. What is the ratio of the Imports (in Local Currency Unit) in 1960 in Sudan to that in Sweden?
Your answer should be very brief. 0. What is the ratio of the Imports (in Local Currency Unit) of 1962 in Sudan to that in Sweden?
Your response must be concise. 0. What is the ratio of the Imports (in Local Currency Unit) of 1960 in Sudan to that in Switzerland?
Give a very brief answer. 0. What is the ratio of the Imports (in Local Currency Unit) of 1961 in Sudan to that in Switzerland?
Ensure brevity in your answer.  0. What is the ratio of the Imports (in Local Currency Unit) of 1962 in Sudan to that in Switzerland?
Offer a very short reply. 0. What is the ratio of the Imports (in Local Currency Unit) of 1962 in Sudan to that in Thailand?
Keep it short and to the point. 0. What is the ratio of the Imports (in Local Currency Unit) in 1962 in Sudan to that in Togo?
Ensure brevity in your answer.  0. What is the ratio of the Imports (in Local Currency Unit) in 1963 in Sudan to that in Togo?
Make the answer very short. 0. What is the ratio of the Imports (in Local Currency Unit) of 1960 in Sudan to that in Trinidad and Tobago?
Offer a very short reply. 0. What is the ratio of the Imports (in Local Currency Unit) in 1962 in Sudan to that in Trinidad and Tobago?
Offer a very short reply. 0. What is the ratio of the Imports (in Local Currency Unit) in 1963 in Sudan to that in Trinidad and Tobago?
Keep it short and to the point. 0. What is the ratio of the Imports (in Local Currency Unit) in 1960 in Sweden to that in Switzerland?
Give a very brief answer. 1.62. What is the ratio of the Imports (in Local Currency Unit) of 1961 in Sweden to that in Switzerland?
Provide a succinct answer. 1.35. What is the ratio of the Imports (in Local Currency Unit) in 1962 in Sweden to that in Switzerland?
Make the answer very short. 1.29. What is the ratio of the Imports (in Local Currency Unit) of 1963 in Sweden to that in Switzerland?
Offer a terse response. 1.31. What is the ratio of the Imports (in Local Currency Unit) in 1960 in Sweden to that in Thailand?
Provide a succinct answer. 1.77. What is the ratio of the Imports (in Local Currency Unit) of 1961 in Sweden to that in Thailand?
Ensure brevity in your answer.  1.66. What is the ratio of the Imports (in Local Currency Unit) in 1962 in Sweden to that in Thailand?
Offer a very short reply. 1.59. What is the ratio of the Imports (in Local Currency Unit) in 1963 in Sweden to that in Thailand?
Ensure brevity in your answer.  1.56. What is the ratio of the Imports (in Local Currency Unit) of 1960 in Sweden to that in Togo?
Offer a terse response. 1.92. What is the ratio of the Imports (in Local Currency Unit) of 1961 in Sweden to that in Togo?
Offer a terse response. 1.93. What is the ratio of the Imports (in Local Currency Unit) of 1962 in Sweden to that in Togo?
Offer a very short reply. 1.97. What is the ratio of the Imports (in Local Currency Unit) in 1963 in Sweden to that in Togo?
Offer a very short reply. 2.02. What is the ratio of the Imports (in Local Currency Unit) of 1960 in Sweden to that in Trinidad and Tobago?
Your response must be concise. 32.01. What is the ratio of the Imports (in Local Currency Unit) of 1961 in Sweden to that in Trinidad and Tobago?
Your response must be concise. 27.92. What is the ratio of the Imports (in Local Currency Unit) in 1962 in Sweden to that in Trinidad and Tobago?
Keep it short and to the point. 28.47. What is the ratio of the Imports (in Local Currency Unit) of 1963 in Sweden to that in Trinidad and Tobago?
Give a very brief answer. 29.89. What is the ratio of the Imports (in Local Currency Unit) in 1960 in Switzerland to that in Thailand?
Your answer should be very brief. 1.09. What is the ratio of the Imports (in Local Currency Unit) of 1961 in Switzerland to that in Thailand?
Ensure brevity in your answer.  1.23. What is the ratio of the Imports (in Local Currency Unit) in 1962 in Switzerland to that in Thailand?
Provide a short and direct response. 1.23. What is the ratio of the Imports (in Local Currency Unit) in 1963 in Switzerland to that in Thailand?
Make the answer very short. 1.19. What is the ratio of the Imports (in Local Currency Unit) in 1960 in Switzerland to that in Togo?
Ensure brevity in your answer.  1.19. What is the ratio of the Imports (in Local Currency Unit) in 1961 in Switzerland to that in Togo?
Provide a succinct answer. 1.43. What is the ratio of the Imports (in Local Currency Unit) in 1962 in Switzerland to that in Togo?
Provide a succinct answer. 1.52. What is the ratio of the Imports (in Local Currency Unit) of 1963 in Switzerland to that in Togo?
Provide a short and direct response. 1.54. What is the ratio of the Imports (in Local Currency Unit) in 1960 in Switzerland to that in Trinidad and Tobago?
Provide a short and direct response. 19.81. What is the ratio of the Imports (in Local Currency Unit) in 1961 in Switzerland to that in Trinidad and Tobago?
Offer a terse response. 20.68. What is the ratio of the Imports (in Local Currency Unit) in 1962 in Switzerland to that in Trinidad and Tobago?
Provide a succinct answer. 22.02. What is the ratio of the Imports (in Local Currency Unit) of 1963 in Switzerland to that in Trinidad and Tobago?
Keep it short and to the point. 22.89. What is the ratio of the Imports (in Local Currency Unit) in 1960 in Thailand to that in Togo?
Make the answer very short. 1.09. What is the ratio of the Imports (in Local Currency Unit) of 1962 in Thailand to that in Togo?
Make the answer very short. 1.24. What is the ratio of the Imports (in Local Currency Unit) of 1963 in Thailand to that in Togo?
Give a very brief answer. 1.29. What is the ratio of the Imports (in Local Currency Unit) of 1960 in Thailand to that in Trinidad and Tobago?
Keep it short and to the point. 18.11. What is the ratio of the Imports (in Local Currency Unit) in 1961 in Thailand to that in Trinidad and Tobago?
Offer a terse response. 16.85. What is the ratio of the Imports (in Local Currency Unit) of 1962 in Thailand to that in Trinidad and Tobago?
Ensure brevity in your answer.  17.92. What is the ratio of the Imports (in Local Currency Unit) of 1963 in Thailand to that in Trinidad and Tobago?
Your answer should be compact. 19.2. What is the ratio of the Imports (in Local Currency Unit) in 1960 in Togo to that in Trinidad and Tobago?
Provide a short and direct response. 16.67. What is the ratio of the Imports (in Local Currency Unit) of 1961 in Togo to that in Trinidad and Tobago?
Ensure brevity in your answer.  14.44. What is the ratio of the Imports (in Local Currency Unit) of 1962 in Togo to that in Trinidad and Tobago?
Provide a short and direct response. 14.48. What is the ratio of the Imports (in Local Currency Unit) in 1963 in Togo to that in Trinidad and Tobago?
Your answer should be compact. 14.83. What is the difference between the highest and the second highest Imports (in Local Currency Unit) in 1960?
Give a very brief answer. 6.86e+09. What is the difference between the highest and the second highest Imports (in Local Currency Unit) of 1961?
Give a very brief answer. 4.70e+09. What is the difference between the highest and the second highest Imports (in Local Currency Unit) in 1962?
Provide a short and direct response. 4.39e+09. What is the difference between the highest and the second highest Imports (in Local Currency Unit) of 1963?
Provide a succinct answer. 4.94e+09. What is the difference between the highest and the lowest Imports (in Local Currency Unit) in 1960?
Your answer should be compact. 1.80e+1. What is the difference between the highest and the lowest Imports (in Local Currency Unit) in 1961?
Make the answer very short. 1.81e+1. What is the difference between the highest and the lowest Imports (in Local Currency Unit) in 1962?
Offer a very short reply. 1.94e+1. What is the difference between the highest and the lowest Imports (in Local Currency Unit) of 1963?
Give a very brief answer. 2.11e+1. 